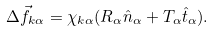<formula> <loc_0><loc_0><loc_500><loc_500>\Delta \vec { f } _ { k \alpha } = \chi _ { k \alpha } ( R _ { \alpha } \hat { n } _ { \alpha } + T _ { \alpha } \hat { t } _ { \alpha } ) .</formula> 